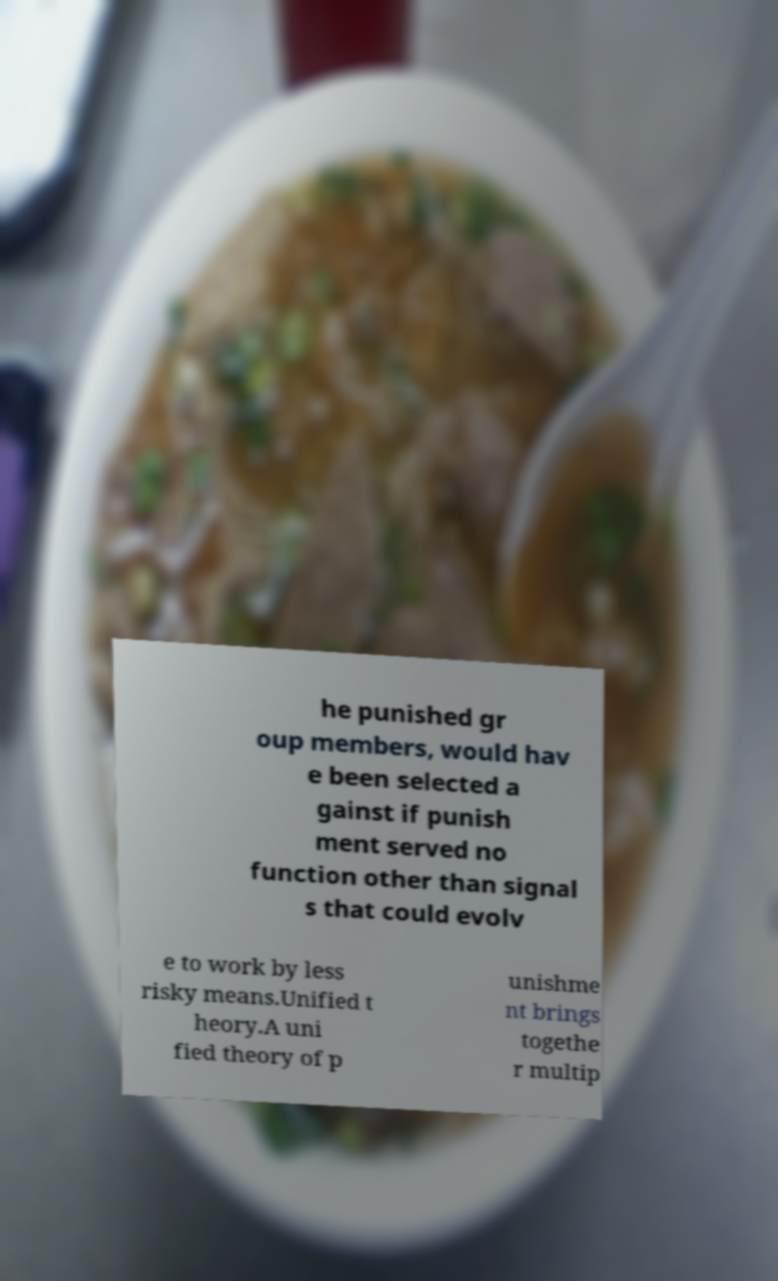Please identify and transcribe the text found in this image. he punished gr oup members, would hav e been selected a gainst if punish ment served no function other than signal s that could evolv e to work by less risky means.Unified t heory.A uni fied theory of p unishme nt brings togethe r multip 